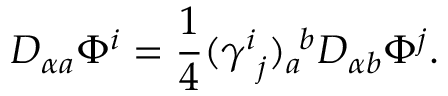<formula> <loc_0><loc_0><loc_500><loc_500>D _ { \alpha a } \Phi ^ { i } = { \frac { 1 } { 4 } } ( \gamma _ { \ j } ^ { i } ) _ { a } ^ { \ b } D _ { \alpha b } \Phi ^ { j } .</formula> 